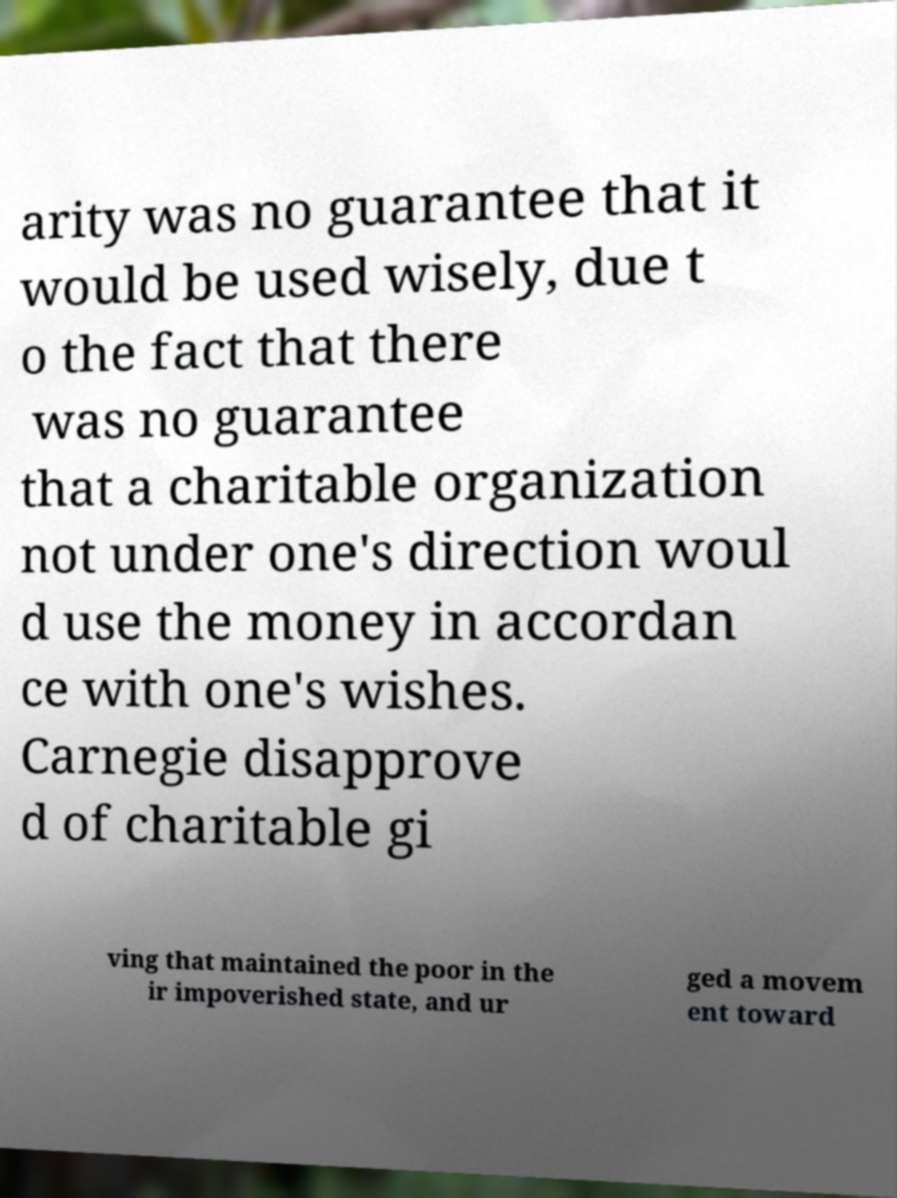Can you read and provide the text displayed in the image?This photo seems to have some interesting text. Can you extract and type it out for me? arity was no guarantee that it would be used wisely, due t o the fact that there was no guarantee that a charitable organization not under one's direction woul d use the money in accordan ce with one's wishes. Carnegie disapprove d of charitable gi ving that maintained the poor in the ir impoverished state, and ur ged a movem ent toward 